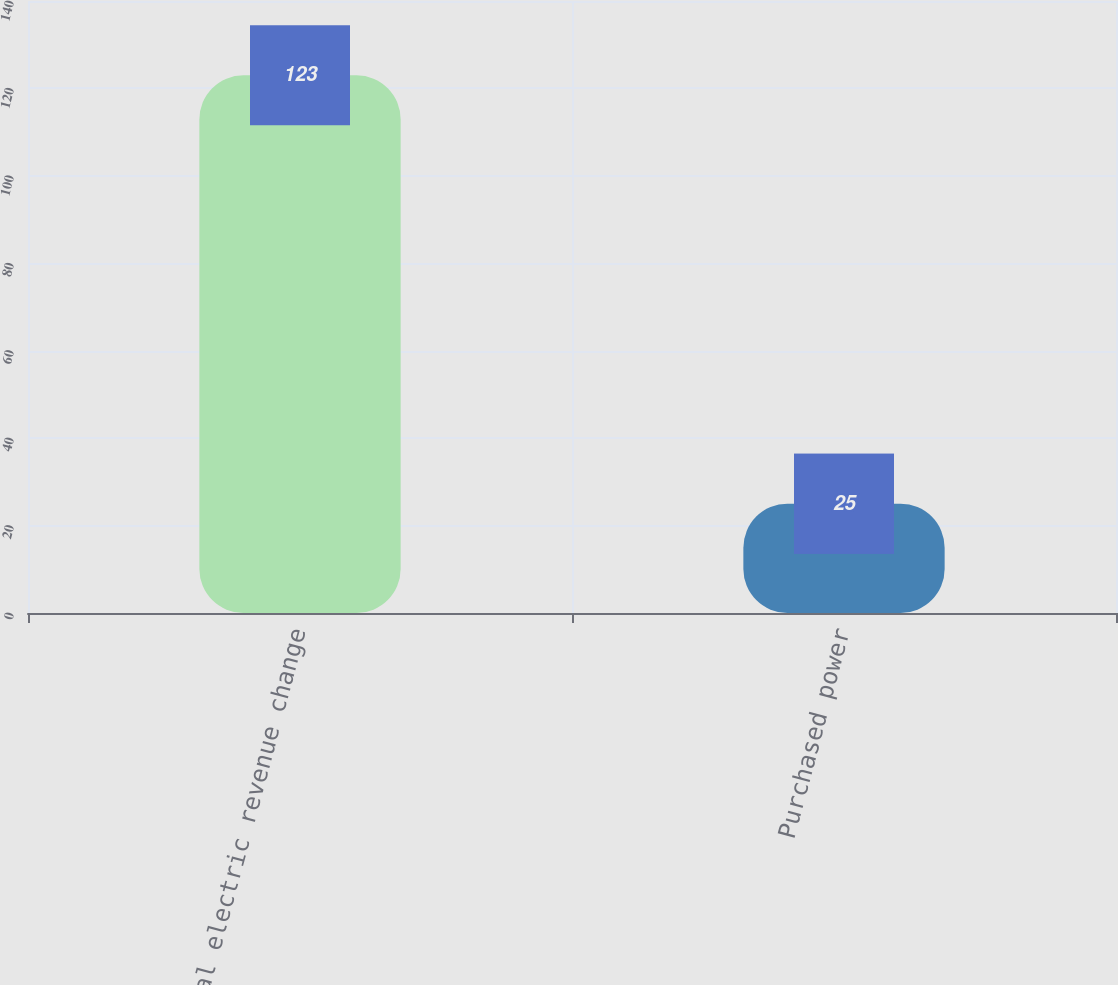Convert chart to OTSL. <chart><loc_0><loc_0><loc_500><loc_500><bar_chart><fcel>Total electric revenue change<fcel>Purchased power<nl><fcel>123<fcel>25<nl></chart> 